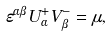Convert formula to latex. <formula><loc_0><loc_0><loc_500><loc_500>\varepsilon ^ { \alpha \beta } U _ { \alpha } ^ { + } V _ { \beta } ^ { - } = \mu ,</formula> 